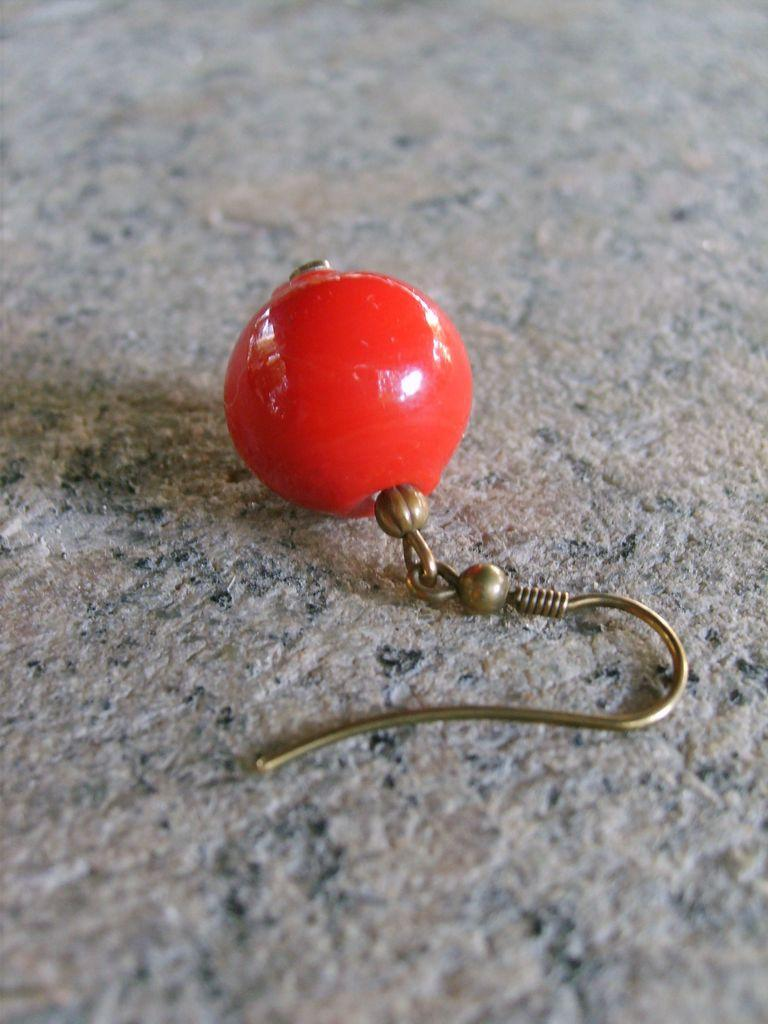What is placed on the floor in the image? There is an earring placed on the floor in the image. Is the earring accompanied by any other objects or figures? The image only shows an earring placed on the floor. What type of snail is crawling on the earring in the image? There is no snail present in the image; it only shows an earring placed on the floor. 